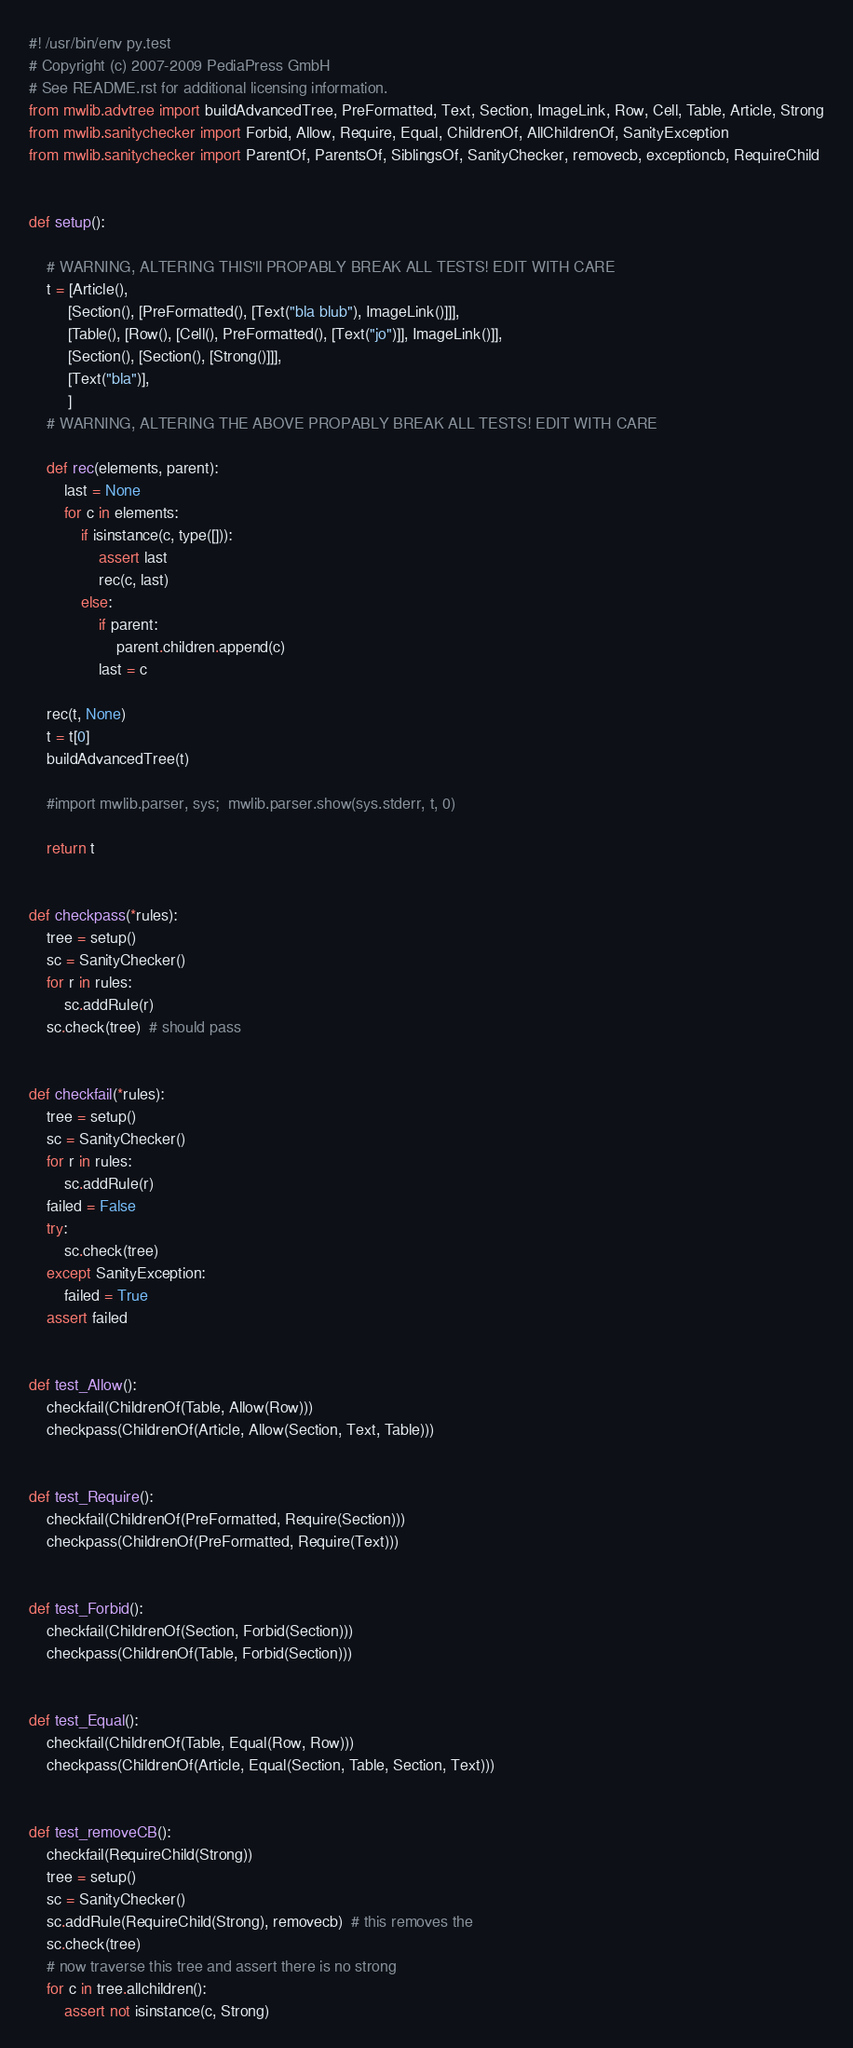<code> <loc_0><loc_0><loc_500><loc_500><_Python_>#! /usr/bin/env py.test
# Copyright (c) 2007-2009 PediaPress GmbH
# See README.rst for additional licensing information.
from mwlib.advtree import buildAdvancedTree, PreFormatted, Text, Section, ImageLink, Row, Cell, Table, Article, Strong
from mwlib.sanitychecker import Forbid, Allow, Require, Equal, ChildrenOf, AllChildrenOf, SanityException
from mwlib.sanitychecker import ParentOf, ParentsOf, SiblingsOf, SanityChecker, removecb, exceptioncb, RequireChild


def setup():

    # WARNING, ALTERING THIS'll PROPABLY BREAK ALL TESTS! EDIT WITH CARE
    t = [Article(),
         [Section(), [PreFormatted(), [Text("bla blub"), ImageLink()]]],
         [Table(), [Row(), [Cell(), PreFormatted(), [Text("jo")]], ImageLink()]],
         [Section(), [Section(), [Strong()]]],
         [Text("bla")],
         ]
    # WARNING, ALTERING THE ABOVE PROPABLY BREAK ALL TESTS! EDIT WITH CARE

    def rec(elements, parent):
        last = None
        for c in elements:
            if isinstance(c, type([])):
                assert last
                rec(c, last)
            else:
                if parent:
                    parent.children.append(c)
                last = c

    rec(t, None)
    t = t[0]
    buildAdvancedTree(t)

    #import mwlib.parser, sys;  mwlib.parser.show(sys.stderr, t, 0)

    return t


def checkpass(*rules):
    tree = setup()
    sc = SanityChecker()
    for r in rules:
        sc.addRule(r)
    sc.check(tree)  # should pass


def checkfail(*rules):
    tree = setup()
    sc = SanityChecker()
    for r in rules:
        sc.addRule(r)
    failed = False
    try:
        sc.check(tree)
    except SanityException:
        failed = True
    assert failed


def test_Allow():
    checkfail(ChildrenOf(Table, Allow(Row)))
    checkpass(ChildrenOf(Article, Allow(Section, Text, Table)))


def test_Require():
    checkfail(ChildrenOf(PreFormatted, Require(Section)))
    checkpass(ChildrenOf(PreFormatted, Require(Text)))


def test_Forbid():
    checkfail(ChildrenOf(Section, Forbid(Section)))
    checkpass(ChildrenOf(Table, Forbid(Section)))


def test_Equal():
    checkfail(ChildrenOf(Table, Equal(Row, Row)))
    checkpass(ChildrenOf(Article, Equal(Section, Table, Section, Text)))


def test_removeCB():
    checkfail(RequireChild(Strong))
    tree = setup()
    sc = SanityChecker()
    sc.addRule(RequireChild(Strong), removecb)  # this removes the
    sc.check(tree)
    # now traverse this tree and assert there is no strong
    for c in tree.allchildren():
        assert not isinstance(c, Strong)
</code> 